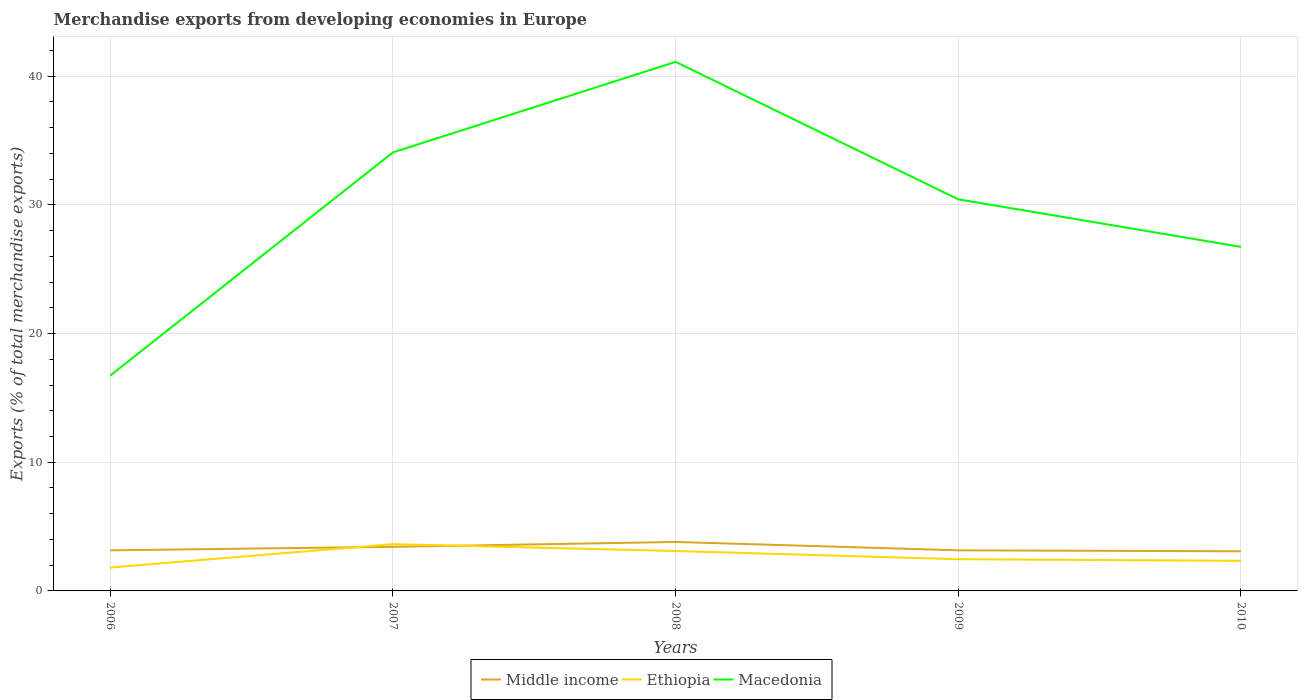How many different coloured lines are there?
Your answer should be very brief. 3. Across all years, what is the maximum percentage of total merchandise exports in Macedonia?
Offer a very short reply. 16.74. In which year was the percentage of total merchandise exports in Middle income maximum?
Offer a very short reply. 2010. What is the total percentage of total merchandise exports in Ethiopia in the graph?
Provide a succinct answer. -1.28. What is the difference between the highest and the second highest percentage of total merchandise exports in Middle income?
Offer a very short reply. 0.73. What is the difference between the highest and the lowest percentage of total merchandise exports in Ethiopia?
Your response must be concise. 2. What is the difference between two consecutive major ticks on the Y-axis?
Provide a succinct answer. 10. Are the values on the major ticks of Y-axis written in scientific E-notation?
Provide a succinct answer. No. Does the graph contain any zero values?
Keep it short and to the point. No. How are the legend labels stacked?
Keep it short and to the point. Horizontal. What is the title of the graph?
Your answer should be compact. Merchandise exports from developing economies in Europe. What is the label or title of the X-axis?
Provide a succinct answer. Years. What is the label or title of the Y-axis?
Your response must be concise. Exports (% of total merchandise exports). What is the Exports (% of total merchandise exports) in Middle income in 2006?
Provide a succinct answer. 3.15. What is the Exports (% of total merchandise exports) of Ethiopia in 2006?
Provide a succinct answer. 1.82. What is the Exports (% of total merchandise exports) in Macedonia in 2006?
Provide a succinct answer. 16.74. What is the Exports (% of total merchandise exports) in Middle income in 2007?
Provide a succinct answer. 3.43. What is the Exports (% of total merchandise exports) in Ethiopia in 2007?
Give a very brief answer. 3.64. What is the Exports (% of total merchandise exports) in Macedonia in 2007?
Keep it short and to the point. 34.08. What is the Exports (% of total merchandise exports) in Middle income in 2008?
Ensure brevity in your answer.  3.81. What is the Exports (% of total merchandise exports) in Ethiopia in 2008?
Give a very brief answer. 3.1. What is the Exports (% of total merchandise exports) of Macedonia in 2008?
Make the answer very short. 41.12. What is the Exports (% of total merchandise exports) of Middle income in 2009?
Offer a very short reply. 3.16. What is the Exports (% of total merchandise exports) of Ethiopia in 2009?
Give a very brief answer. 2.46. What is the Exports (% of total merchandise exports) in Macedonia in 2009?
Provide a succinct answer. 30.43. What is the Exports (% of total merchandise exports) of Middle income in 2010?
Your answer should be compact. 3.08. What is the Exports (% of total merchandise exports) in Ethiopia in 2010?
Ensure brevity in your answer.  2.34. What is the Exports (% of total merchandise exports) in Macedonia in 2010?
Provide a short and direct response. 26.74. Across all years, what is the maximum Exports (% of total merchandise exports) of Middle income?
Make the answer very short. 3.81. Across all years, what is the maximum Exports (% of total merchandise exports) of Ethiopia?
Keep it short and to the point. 3.64. Across all years, what is the maximum Exports (% of total merchandise exports) in Macedonia?
Offer a terse response. 41.12. Across all years, what is the minimum Exports (% of total merchandise exports) of Middle income?
Your answer should be very brief. 3.08. Across all years, what is the minimum Exports (% of total merchandise exports) of Ethiopia?
Keep it short and to the point. 1.82. Across all years, what is the minimum Exports (% of total merchandise exports) of Macedonia?
Your answer should be very brief. 16.74. What is the total Exports (% of total merchandise exports) of Middle income in the graph?
Keep it short and to the point. 16.62. What is the total Exports (% of total merchandise exports) of Ethiopia in the graph?
Provide a succinct answer. 13.36. What is the total Exports (% of total merchandise exports) in Macedonia in the graph?
Offer a very short reply. 149.11. What is the difference between the Exports (% of total merchandise exports) of Middle income in 2006 and that in 2007?
Ensure brevity in your answer.  -0.27. What is the difference between the Exports (% of total merchandise exports) of Ethiopia in 2006 and that in 2007?
Your answer should be compact. -1.82. What is the difference between the Exports (% of total merchandise exports) of Macedonia in 2006 and that in 2007?
Keep it short and to the point. -17.35. What is the difference between the Exports (% of total merchandise exports) of Middle income in 2006 and that in 2008?
Your answer should be compact. -0.65. What is the difference between the Exports (% of total merchandise exports) in Ethiopia in 2006 and that in 2008?
Provide a succinct answer. -1.28. What is the difference between the Exports (% of total merchandise exports) of Macedonia in 2006 and that in 2008?
Provide a short and direct response. -24.38. What is the difference between the Exports (% of total merchandise exports) of Middle income in 2006 and that in 2009?
Your response must be concise. -0. What is the difference between the Exports (% of total merchandise exports) in Ethiopia in 2006 and that in 2009?
Provide a short and direct response. -0.65. What is the difference between the Exports (% of total merchandise exports) in Macedonia in 2006 and that in 2009?
Your response must be concise. -13.7. What is the difference between the Exports (% of total merchandise exports) in Middle income in 2006 and that in 2010?
Your answer should be very brief. 0.08. What is the difference between the Exports (% of total merchandise exports) in Ethiopia in 2006 and that in 2010?
Make the answer very short. -0.52. What is the difference between the Exports (% of total merchandise exports) in Macedonia in 2006 and that in 2010?
Keep it short and to the point. -10. What is the difference between the Exports (% of total merchandise exports) of Middle income in 2007 and that in 2008?
Keep it short and to the point. -0.38. What is the difference between the Exports (% of total merchandise exports) of Ethiopia in 2007 and that in 2008?
Ensure brevity in your answer.  0.54. What is the difference between the Exports (% of total merchandise exports) of Macedonia in 2007 and that in 2008?
Provide a succinct answer. -7.04. What is the difference between the Exports (% of total merchandise exports) of Middle income in 2007 and that in 2009?
Offer a very short reply. 0.27. What is the difference between the Exports (% of total merchandise exports) in Ethiopia in 2007 and that in 2009?
Ensure brevity in your answer.  1.17. What is the difference between the Exports (% of total merchandise exports) in Macedonia in 2007 and that in 2009?
Your response must be concise. 3.65. What is the difference between the Exports (% of total merchandise exports) of Middle income in 2007 and that in 2010?
Offer a very short reply. 0.35. What is the difference between the Exports (% of total merchandise exports) of Ethiopia in 2007 and that in 2010?
Ensure brevity in your answer.  1.3. What is the difference between the Exports (% of total merchandise exports) of Macedonia in 2007 and that in 2010?
Make the answer very short. 7.34. What is the difference between the Exports (% of total merchandise exports) in Middle income in 2008 and that in 2009?
Ensure brevity in your answer.  0.65. What is the difference between the Exports (% of total merchandise exports) of Ethiopia in 2008 and that in 2009?
Your answer should be compact. 0.64. What is the difference between the Exports (% of total merchandise exports) in Macedonia in 2008 and that in 2009?
Your answer should be compact. 10.68. What is the difference between the Exports (% of total merchandise exports) of Middle income in 2008 and that in 2010?
Offer a very short reply. 0.73. What is the difference between the Exports (% of total merchandise exports) of Ethiopia in 2008 and that in 2010?
Provide a short and direct response. 0.76. What is the difference between the Exports (% of total merchandise exports) in Macedonia in 2008 and that in 2010?
Offer a terse response. 14.38. What is the difference between the Exports (% of total merchandise exports) of Middle income in 2009 and that in 2010?
Your answer should be very brief. 0.08. What is the difference between the Exports (% of total merchandise exports) in Ethiopia in 2009 and that in 2010?
Your response must be concise. 0.13. What is the difference between the Exports (% of total merchandise exports) in Macedonia in 2009 and that in 2010?
Provide a short and direct response. 3.7. What is the difference between the Exports (% of total merchandise exports) in Middle income in 2006 and the Exports (% of total merchandise exports) in Ethiopia in 2007?
Your answer should be compact. -0.48. What is the difference between the Exports (% of total merchandise exports) of Middle income in 2006 and the Exports (% of total merchandise exports) of Macedonia in 2007?
Provide a short and direct response. -30.93. What is the difference between the Exports (% of total merchandise exports) of Ethiopia in 2006 and the Exports (% of total merchandise exports) of Macedonia in 2007?
Ensure brevity in your answer.  -32.27. What is the difference between the Exports (% of total merchandise exports) of Middle income in 2006 and the Exports (% of total merchandise exports) of Ethiopia in 2008?
Your response must be concise. 0.05. What is the difference between the Exports (% of total merchandise exports) of Middle income in 2006 and the Exports (% of total merchandise exports) of Macedonia in 2008?
Offer a very short reply. -37.96. What is the difference between the Exports (% of total merchandise exports) in Ethiopia in 2006 and the Exports (% of total merchandise exports) in Macedonia in 2008?
Give a very brief answer. -39.3. What is the difference between the Exports (% of total merchandise exports) in Middle income in 2006 and the Exports (% of total merchandise exports) in Ethiopia in 2009?
Keep it short and to the point. 0.69. What is the difference between the Exports (% of total merchandise exports) in Middle income in 2006 and the Exports (% of total merchandise exports) in Macedonia in 2009?
Provide a short and direct response. -27.28. What is the difference between the Exports (% of total merchandise exports) of Ethiopia in 2006 and the Exports (% of total merchandise exports) of Macedonia in 2009?
Give a very brief answer. -28.62. What is the difference between the Exports (% of total merchandise exports) of Middle income in 2006 and the Exports (% of total merchandise exports) of Ethiopia in 2010?
Make the answer very short. 0.82. What is the difference between the Exports (% of total merchandise exports) in Middle income in 2006 and the Exports (% of total merchandise exports) in Macedonia in 2010?
Make the answer very short. -23.58. What is the difference between the Exports (% of total merchandise exports) in Ethiopia in 2006 and the Exports (% of total merchandise exports) in Macedonia in 2010?
Keep it short and to the point. -24.92. What is the difference between the Exports (% of total merchandise exports) in Middle income in 2007 and the Exports (% of total merchandise exports) in Ethiopia in 2008?
Ensure brevity in your answer.  0.33. What is the difference between the Exports (% of total merchandise exports) in Middle income in 2007 and the Exports (% of total merchandise exports) in Macedonia in 2008?
Provide a succinct answer. -37.69. What is the difference between the Exports (% of total merchandise exports) of Ethiopia in 2007 and the Exports (% of total merchandise exports) of Macedonia in 2008?
Offer a very short reply. -37.48. What is the difference between the Exports (% of total merchandise exports) of Middle income in 2007 and the Exports (% of total merchandise exports) of Ethiopia in 2009?
Your response must be concise. 0.96. What is the difference between the Exports (% of total merchandise exports) of Middle income in 2007 and the Exports (% of total merchandise exports) of Macedonia in 2009?
Offer a terse response. -27.01. What is the difference between the Exports (% of total merchandise exports) in Ethiopia in 2007 and the Exports (% of total merchandise exports) in Macedonia in 2009?
Make the answer very short. -26.8. What is the difference between the Exports (% of total merchandise exports) in Middle income in 2007 and the Exports (% of total merchandise exports) in Ethiopia in 2010?
Your answer should be compact. 1.09. What is the difference between the Exports (% of total merchandise exports) in Middle income in 2007 and the Exports (% of total merchandise exports) in Macedonia in 2010?
Offer a terse response. -23.31. What is the difference between the Exports (% of total merchandise exports) of Ethiopia in 2007 and the Exports (% of total merchandise exports) of Macedonia in 2010?
Offer a very short reply. -23.1. What is the difference between the Exports (% of total merchandise exports) of Middle income in 2008 and the Exports (% of total merchandise exports) of Ethiopia in 2009?
Give a very brief answer. 1.34. What is the difference between the Exports (% of total merchandise exports) in Middle income in 2008 and the Exports (% of total merchandise exports) in Macedonia in 2009?
Provide a short and direct response. -26.63. What is the difference between the Exports (% of total merchandise exports) of Ethiopia in 2008 and the Exports (% of total merchandise exports) of Macedonia in 2009?
Your answer should be very brief. -27.33. What is the difference between the Exports (% of total merchandise exports) of Middle income in 2008 and the Exports (% of total merchandise exports) of Ethiopia in 2010?
Give a very brief answer. 1.47. What is the difference between the Exports (% of total merchandise exports) in Middle income in 2008 and the Exports (% of total merchandise exports) in Macedonia in 2010?
Keep it short and to the point. -22.93. What is the difference between the Exports (% of total merchandise exports) of Ethiopia in 2008 and the Exports (% of total merchandise exports) of Macedonia in 2010?
Your response must be concise. -23.64. What is the difference between the Exports (% of total merchandise exports) in Middle income in 2009 and the Exports (% of total merchandise exports) in Ethiopia in 2010?
Make the answer very short. 0.82. What is the difference between the Exports (% of total merchandise exports) of Middle income in 2009 and the Exports (% of total merchandise exports) of Macedonia in 2010?
Make the answer very short. -23.58. What is the difference between the Exports (% of total merchandise exports) of Ethiopia in 2009 and the Exports (% of total merchandise exports) of Macedonia in 2010?
Provide a succinct answer. -24.27. What is the average Exports (% of total merchandise exports) in Middle income per year?
Provide a short and direct response. 3.32. What is the average Exports (% of total merchandise exports) in Ethiopia per year?
Offer a terse response. 2.67. What is the average Exports (% of total merchandise exports) of Macedonia per year?
Make the answer very short. 29.82. In the year 2006, what is the difference between the Exports (% of total merchandise exports) in Middle income and Exports (% of total merchandise exports) in Ethiopia?
Your answer should be very brief. 1.34. In the year 2006, what is the difference between the Exports (% of total merchandise exports) of Middle income and Exports (% of total merchandise exports) of Macedonia?
Your answer should be compact. -13.58. In the year 2006, what is the difference between the Exports (% of total merchandise exports) of Ethiopia and Exports (% of total merchandise exports) of Macedonia?
Offer a terse response. -14.92. In the year 2007, what is the difference between the Exports (% of total merchandise exports) in Middle income and Exports (% of total merchandise exports) in Ethiopia?
Your answer should be compact. -0.21. In the year 2007, what is the difference between the Exports (% of total merchandise exports) of Middle income and Exports (% of total merchandise exports) of Macedonia?
Your answer should be very brief. -30.66. In the year 2007, what is the difference between the Exports (% of total merchandise exports) in Ethiopia and Exports (% of total merchandise exports) in Macedonia?
Offer a very short reply. -30.45. In the year 2008, what is the difference between the Exports (% of total merchandise exports) of Middle income and Exports (% of total merchandise exports) of Ethiopia?
Provide a succinct answer. 0.7. In the year 2008, what is the difference between the Exports (% of total merchandise exports) in Middle income and Exports (% of total merchandise exports) in Macedonia?
Your response must be concise. -37.31. In the year 2008, what is the difference between the Exports (% of total merchandise exports) of Ethiopia and Exports (% of total merchandise exports) of Macedonia?
Give a very brief answer. -38.02. In the year 2009, what is the difference between the Exports (% of total merchandise exports) of Middle income and Exports (% of total merchandise exports) of Ethiopia?
Your answer should be very brief. 0.69. In the year 2009, what is the difference between the Exports (% of total merchandise exports) of Middle income and Exports (% of total merchandise exports) of Macedonia?
Give a very brief answer. -27.28. In the year 2009, what is the difference between the Exports (% of total merchandise exports) in Ethiopia and Exports (% of total merchandise exports) in Macedonia?
Provide a short and direct response. -27.97. In the year 2010, what is the difference between the Exports (% of total merchandise exports) in Middle income and Exports (% of total merchandise exports) in Ethiopia?
Provide a short and direct response. 0.74. In the year 2010, what is the difference between the Exports (% of total merchandise exports) in Middle income and Exports (% of total merchandise exports) in Macedonia?
Ensure brevity in your answer.  -23.66. In the year 2010, what is the difference between the Exports (% of total merchandise exports) of Ethiopia and Exports (% of total merchandise exports) of Macedonia?
Offer a terse response. -24.4. What is the ratio of the Exports (% of total merchandise exports) of Middle income in 2006 to that in 2007?
Offer a terse response. 0.92. What is the ratio of the Exports (% of total merchandise exports) of Ethiopia in 2006 to that in 2007?
Your answer should be compact. 0.5. What is the ratio of the Exports (% of total merchandise exports) of Macedonia in 2006 to that in 2007?
Provide a succinct answer. 0.49. What is the ratio of the Exports (% of total merchandise exports) of Middle income in 2006 to that in 2008?
Your answer should be very brief. 0.83. What is the ratio of the Exports (% of total merchandise exports) of Ethiopia in 2006 to that in 2008?
Offer a very short reply. 0.59. What is the ratio of the Exports (% of total merchandise exports) in Macedonia in 2006 to that in 2008?
Your answer should be very brief. 0.41. What is the ratio of the Exports (% of total merchandise exports) of Ethiopia in 2006 to that in 2009?
Your answer should be very brief. 0.74. What is the ratio of the Exports (% of total merchandise exports) of Macedonia in 2006 to that in 2009?
Make the answer very short. 0.55. What is the ratio of the Exports (% of total merchandise exports) in Middle income in 2006 to that in 2010?
Offer a terse response. 1.02. What is the ratio of the Exports (% of total merchandise exports) of Ethiopia in 2006 to that in 2010?
Give a very brief answer. 0.78. What is the ratio of the Exports (% of total merchandise exports) of Macedonia in 2006 to that in 2010?
Your answer should be compact. 0.63. What is the ratio of the Exports (% of total merchandise exports) in Middle income in 2007 to that in 2008?
Your response must be concise. 0.9. What is the ratio of the Exports (% of total merchandise exports) in Ethiopia in 2007 to that in 2008?
Make the answer very short. 1.17. What is the ratio of the Exports (% of total merchandise exports) in Macedonia in 2007 to that in 2008?
Your response must be concise. 0.83. What is the ratio of the Exports (% of total merchandise exports) in Middle income in 2007 to that in 2009?
Your answer should be compact. 1.09. What is the ratio of the Exports (% of total merchandise exports) in Ethiopia in 2007 to that in 2009?
Provide a short and direct response. 1.48. What is the ratio of the Exports (% of total merchandise exports) of Macedonia in 2007 to that in 2009?
Provide a succinct answer. 1.12. What is the ratio of the Exports (% of total merchandise exports) in Middle income in 2007 to that in 2010?
Make the answer very short. 1.11. What is the ratio of the Exports (% of total merchandise exports) of Ethiopia in 2007 to that in 2010?
Your answer should be compact. 1.56. What is the ratio of the Exports (% of total merchandise exports) of Macedonia in 2007 to that in 2010?
Ensure brevity in your answer.  1.27. What is the ratio of the Exports (% of total merchandise exports) of Middle income in 2008 to that in 2009?
Make the answer very short. 1.21. What is the ratio of the Exports (% of total merchandise exports) in Ethiopia in 2008 to that in 2009?
Offer a terse response. 1.26. What is the ratio of the Exports (% of total merchandise exports) of Macedonia in 2008 to that in 2009?
Ensure brevity in your answer.  1.35. What is the ratio of the Exports (% of total merchandise exports) of Middle income in 2008 to that in 2010?
Keep it short and to the point. 1.24. What is the ratio of the Exports (% of total merchandise exports) of Ethiopia in 2008 to that in 2010?
Provide a succinct answer. 1.33. What is the ratio of the Exports (% of total merchandise exports) of Macedonia in 2008 to that in 2010?
Make the answer very short. 1.54. What is the ratio of the Exports (% of total merchandise exports) of Middle income in 2009 to that in 2010?
Ensure brevity in your answer.  1.02. What is the ratio of the Exports (% of total merchandise exports) of Ethiopia in 2009 to that in 2010?
Keep it short and to the point. 1.05. What is the ratio of the Exports (% of total merchandise exports) in Macedonia in 2009 to that in 2010?
Ensure brevity in your answer.  1.14. What is the difference between the highest and the second highest Exports (% of total merchandise exports) in Middle income?
Ensure brevity in your answer.  0.38. What is the difference between the highest and the second highest Exports (% of total merchandise exports) of Ethiopia?
Provide a short and direct response. 0.54. What is the difference between the highest and the second highest Exports (% of total merchandise exports) of Macedonia?
Give a very brief answer. 7.04. What is the difference between the highest and the lowest Exports (% of total merchandise exports) of Middle income?
Give a very brief answer. 0.73. What is the difference between the highest and the lowest Exports (% of total merchandise exports) in Ethiopia?
Offer a very short reply. 1.82. What is the difference between the highest and the lowest Exports (% of total merchandise exports) of Macedonia?
Offer a very short reply. 24.38. 